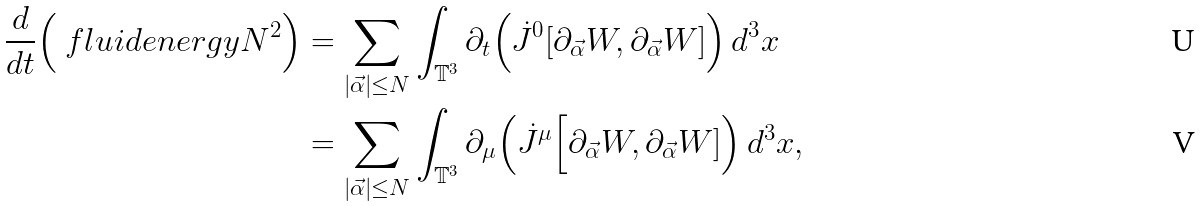<formula> <loc_0><loc_0><loc_500><loc_500>\frac { d } { d t } \Big ( \ f l u i d e n e r g y { N } ^ { 2 } \Big ) & = \sum _ { | \vec { \alpha } | \leq N } \int _ { \mathbb { T } ^ { 3 } } \partial _ { t } \Big ( \dot { J } ^ { 0 } [ \partial _ { \vec { \alpha } } W , \partial _ { \vec { \alpha } } W ] \Big ) \, d ^ { 3 } x \\ & = \sum _ { | \vec { \alpha } | \leq N } \int _ { \mathbb { T } ^ { 3 } } \partial _ { \mu } \Big ( \dot { J } ^ { \mu } \Big [ \partial _ { \vec { \alpha } } W , \partial _ { \vec { \alpha } } W ] \Big ) \, d ^ { 3 } x ,</formula> 